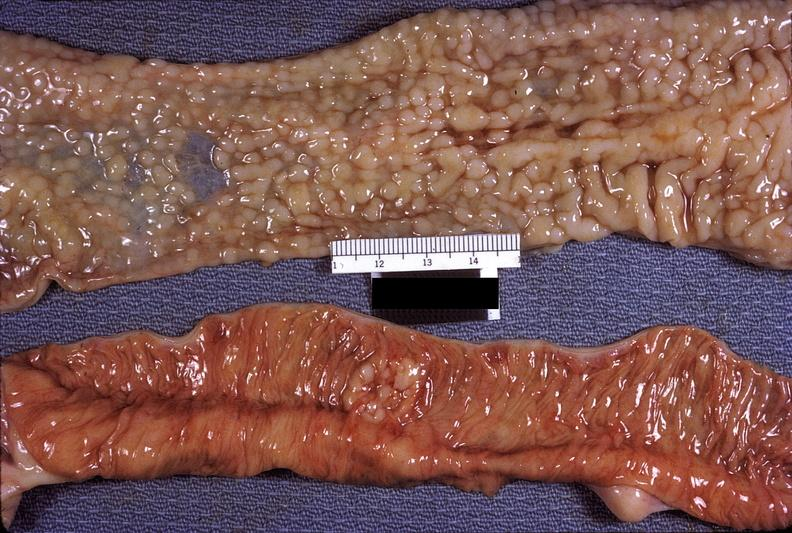does this image show small intestine, hodgkins lymphosarcoma?
Answer the question using a single word or phrase. Yes 